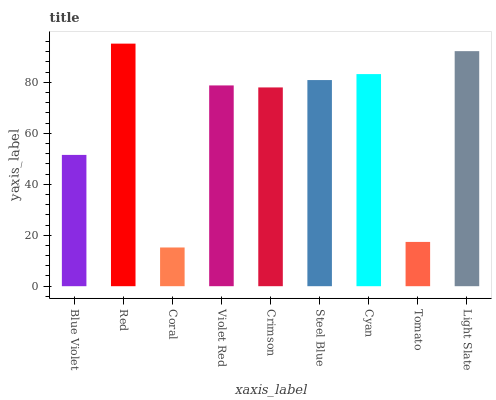Is Coral the minimum?
Answer yes or no. Yes. Is Red the maximum?
Answer yes or no. Yes. Is Red the minimum?
Answer yes or no. No. Is Coral the maximum?
Answer yes or no. No. Is Red greater than Coral?
Answer yes or no. Yes. Is Coral less than Red?
Answer yes or no. Yes. Is Coral greater than Red?
Answer yes or no. No. Is Red less than Coral?
Answer yes or no. No. Is Violet Red the high median?
Answer yes or no. Yes. Is Violet Red the low median?
Answer yes or no. Yes. Is Crimson the high median?
Answer yes or no. No. Is Steel Blue the low median?
Answer yes or no. No. 